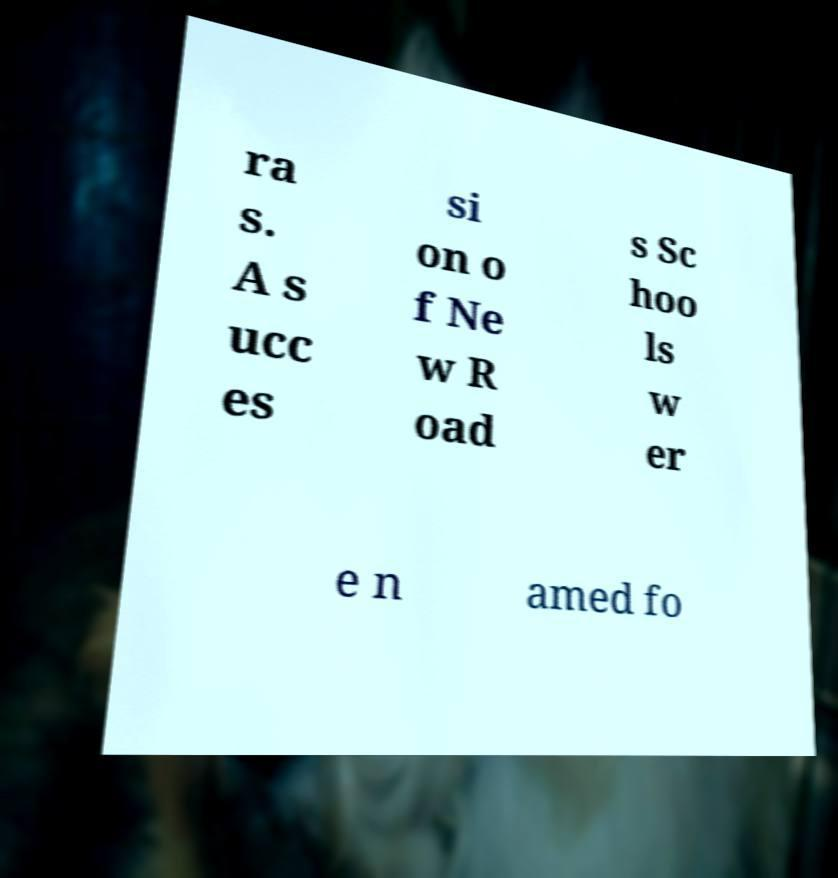There's text embedded in this image that I need extracted. Can you transcribe it verbatim? ra s. A s ucc es si on o f Ne w R oad s Sc hoo ls w er e n amed fo 